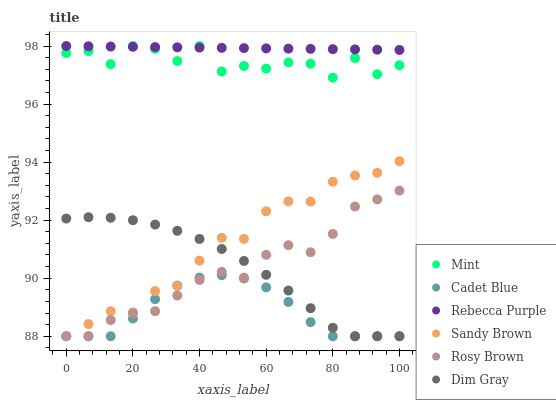Does Cadet Blue have the minimum area under the curve?
Answer yes or no. Yes. Does Rebecca Purple have the maximum area under the curve?
Answer yes or no. Yes. Does Mint have the minimum area under the curve?
Answer yes or no. No. Does Mint have the maximum area under the curve?
Answer yes or no. No. Is Rebecca Purple the smoothest?
Answer yes or no. Yes. Is Mint the roughest?
Answer yes or no. Yes. Is Rosy Brown the smoothest?
Answer yes or no. No. Is Rosy Brown the roughest?
Answer yes or no. No. Does Cadet Blue have the lowest value?
Answer yes or no. Yes. Does Mint have the lowest value?
Answer yes or no. No. Does Rebecca Purple have the highest value?
Answer yes or no. Yes. Does Rosy Brown have the highest value?
Answer yes or no. No. Is Dim Gray less than Mint?
Answer yes or no. Yes. Is Rebecca Purple greater than Dim Gray?
Answer yes or no. Yes. Does Rebecca Purple intersect Mint?
Answer yes or no. Yes. Is Rebecca Purple less than Mint?
Answer yes or no. No. Is Rebecca Purple greater than Mint?
Answer yes or no. No. Does Dim Gray intersect Mint?
Answer yes or no. No. 